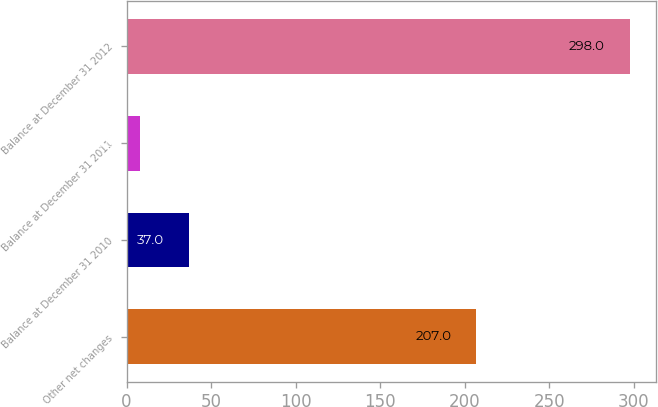Convert chart to OTSL. <chart><loc_0><loc_0><loc_500><loc_500><bar_chart><fcel>Other net changes<fcel>Balance at December 31 2010<fcel>Balance at December 31 2011<fcel>Balance at December 31 2012<nl><fcel>207<fcel>37<fcel>8<fcel>298<nl></chart> 